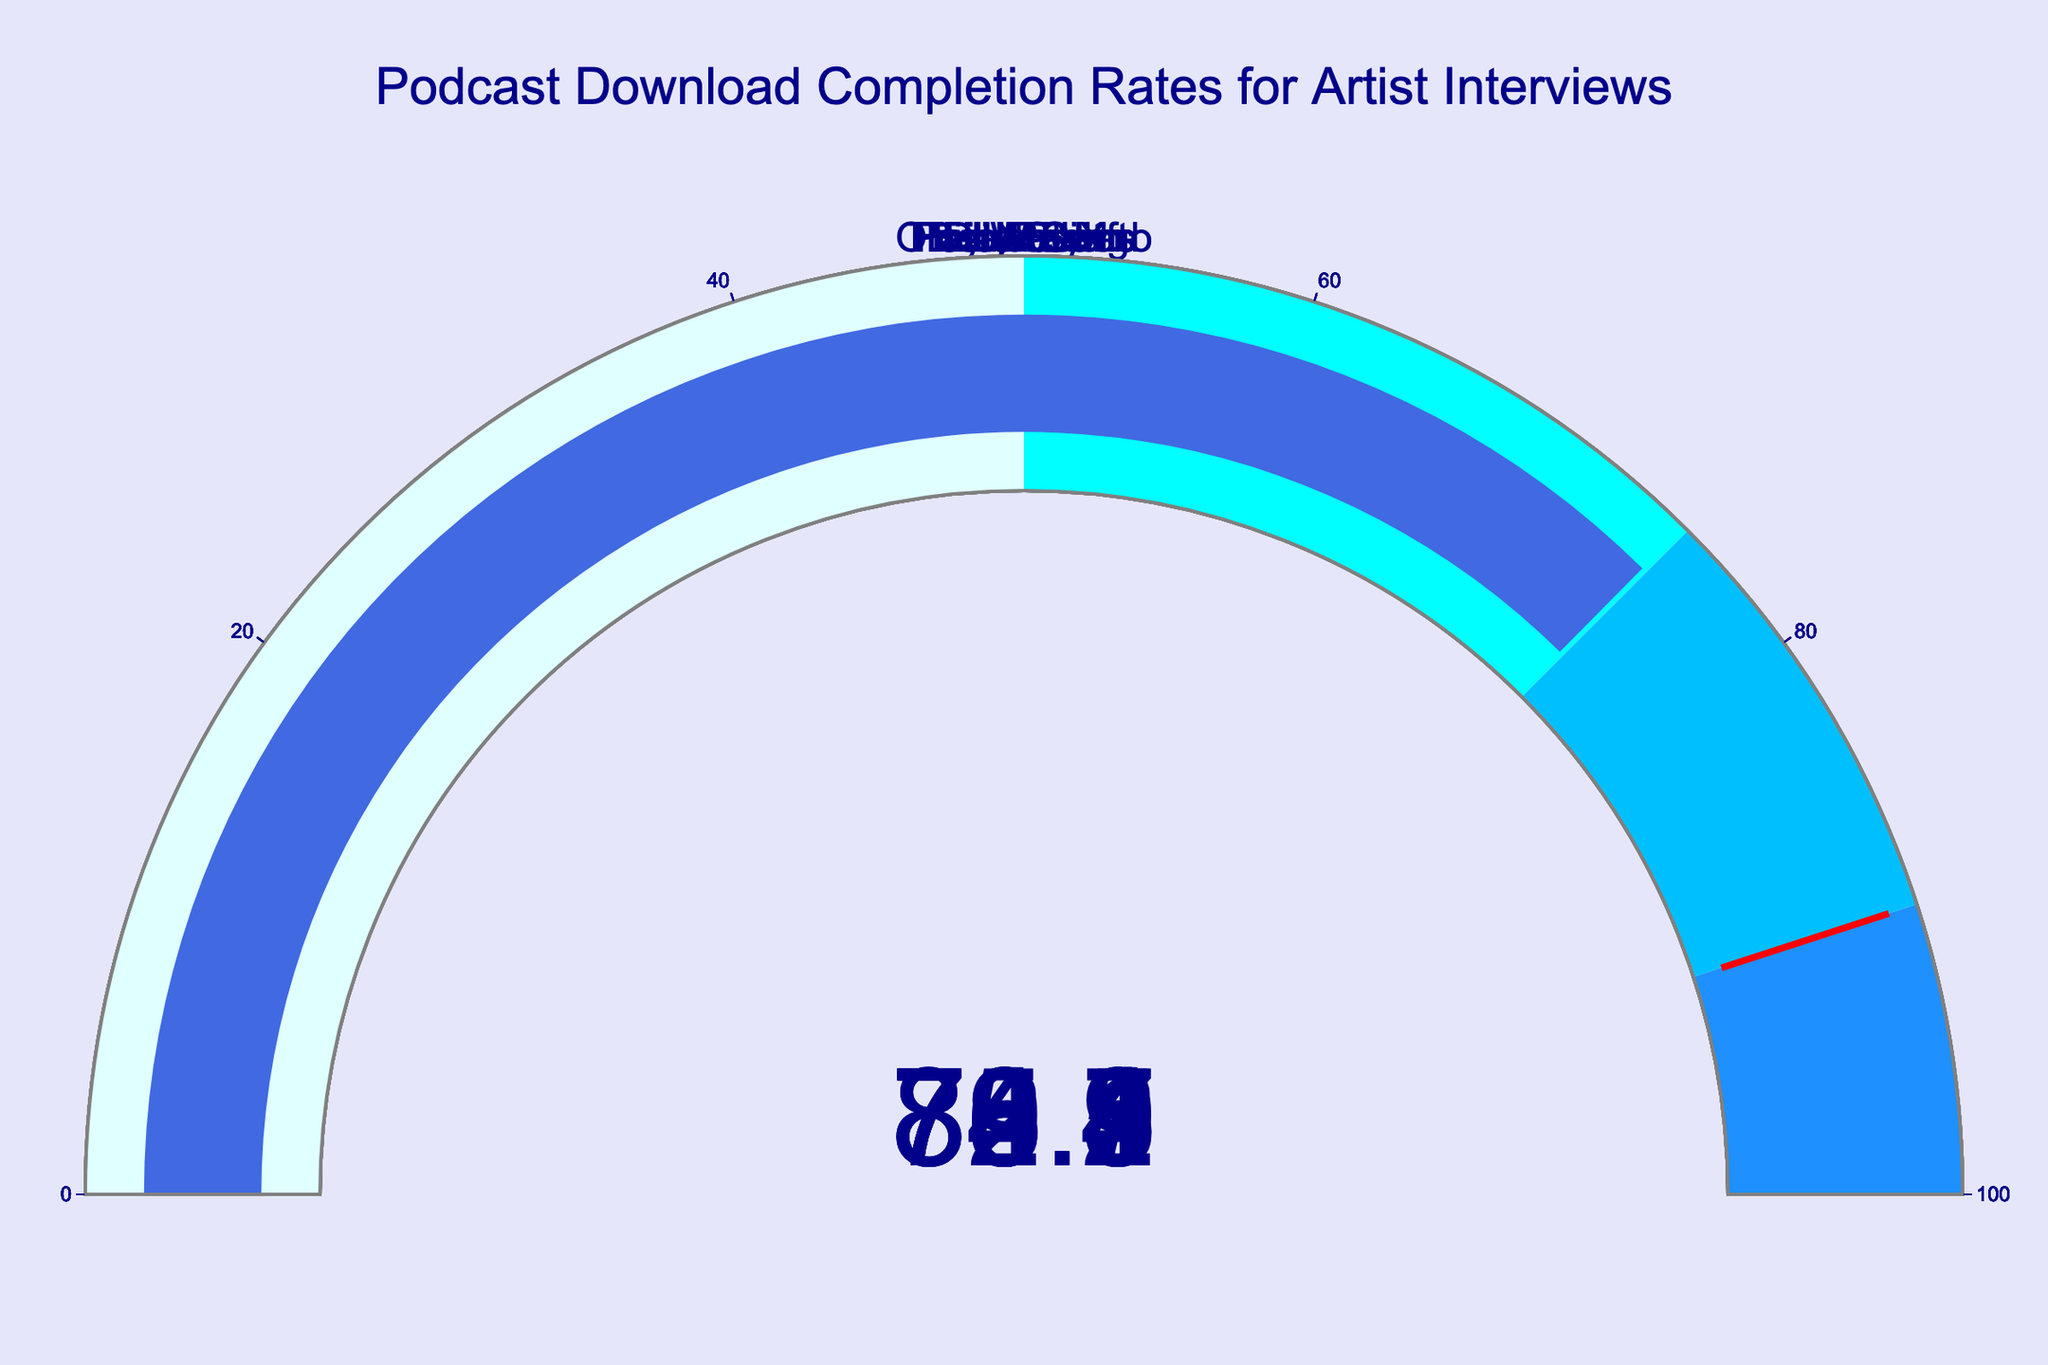Which artist has the highest podcast download completion rate? Locate the gauge with the highest number displayed. Harry Styles has the highest completion rate of 83.2%.
Answer: Harry Styles What's the average podcast download completion rate for the artists? Sum the completion rates for all artists and divide by the number of artists. The sum is 630.9, and there are 8 artists, so the average is 630.9 / 8 = 78.8625.
Answer: 78.86 Which artists have a podcast download completion rate above 80%? Identify the gauges with values above 80%. The artists are Billie Eilish, Olivia Rodrigo, and Harry Styles with rates of 82.3%, 80.1%, and 83.2% respectively.
Answer: Billie Eilish, Olivia Rodrigo, Harry Styles How many artists have a podcast download completion rate below 78%? Count the gauges with values below 78%. The artists are Lil Nas X, The Weeknd, and Post Malone, which are 3 in total.
Answer: 3 What is the completion rate for Taylor Swift's podcast? Look for the gauge corresponding to Taylor Swift and read the number displayed. The completion rate is 78.5%.
Answer: 78.5% By how much does Doja Cat's podcast completion rate differ from The Weeknd's? Subtract The Weeknd's completion rate from Doja Cat's. Doja Cat has 79.4% and The Weeknd has 76.7%, the difference is 79.4 - 76.7 = 2.7%.
Answer: 2.7% If we set a threshold of 75% completion rate, how many artists meet or exceed this threshold? Count the gauges with values of 75% or higher. All artists except Post Malone meet this criterion, so there are 7 artists.
Answer: 7 Which artists' podcast completion rates fall between 75% and 80%? Identify gauges with values between 75% and 80%. The artists are Taylor Swift, Lil Nas X, The Weeknd, and Doja Cat with rates of 78.5%, 75.9%, 76.7%, and 79.4% respectively.
Answer: Taylor Swift, Lil Nas X, The Weeknd, Doja Cat Which artist has the lowest podcast download completion rate? Find the gauge with the lowest number displayed. Post Malone has the lowest completion rate of 74.8%.
Answer: Post Malone 